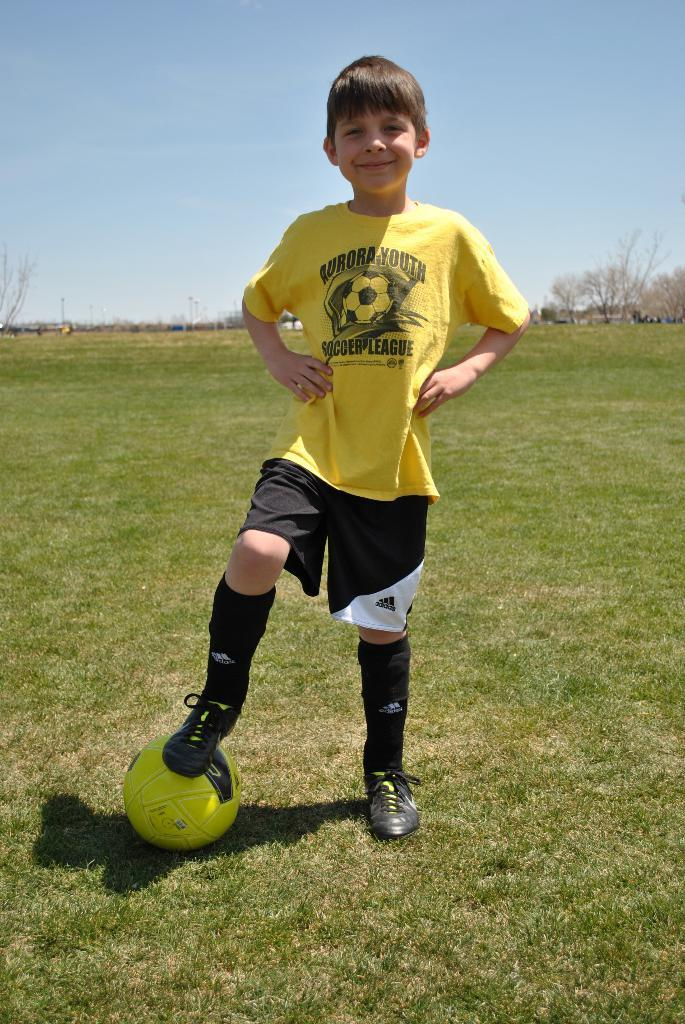What is the main subject of the image? There is a boy standing in the image. How is the boy's facial expression in the image? The boy has a smile on his face. What object is visible in the image besides the boy? There is a ball visible in the image. What advice is the boy giving to the person in the hall in the image? There is no person in the hall in the image, and the boy is not giving any advice. 